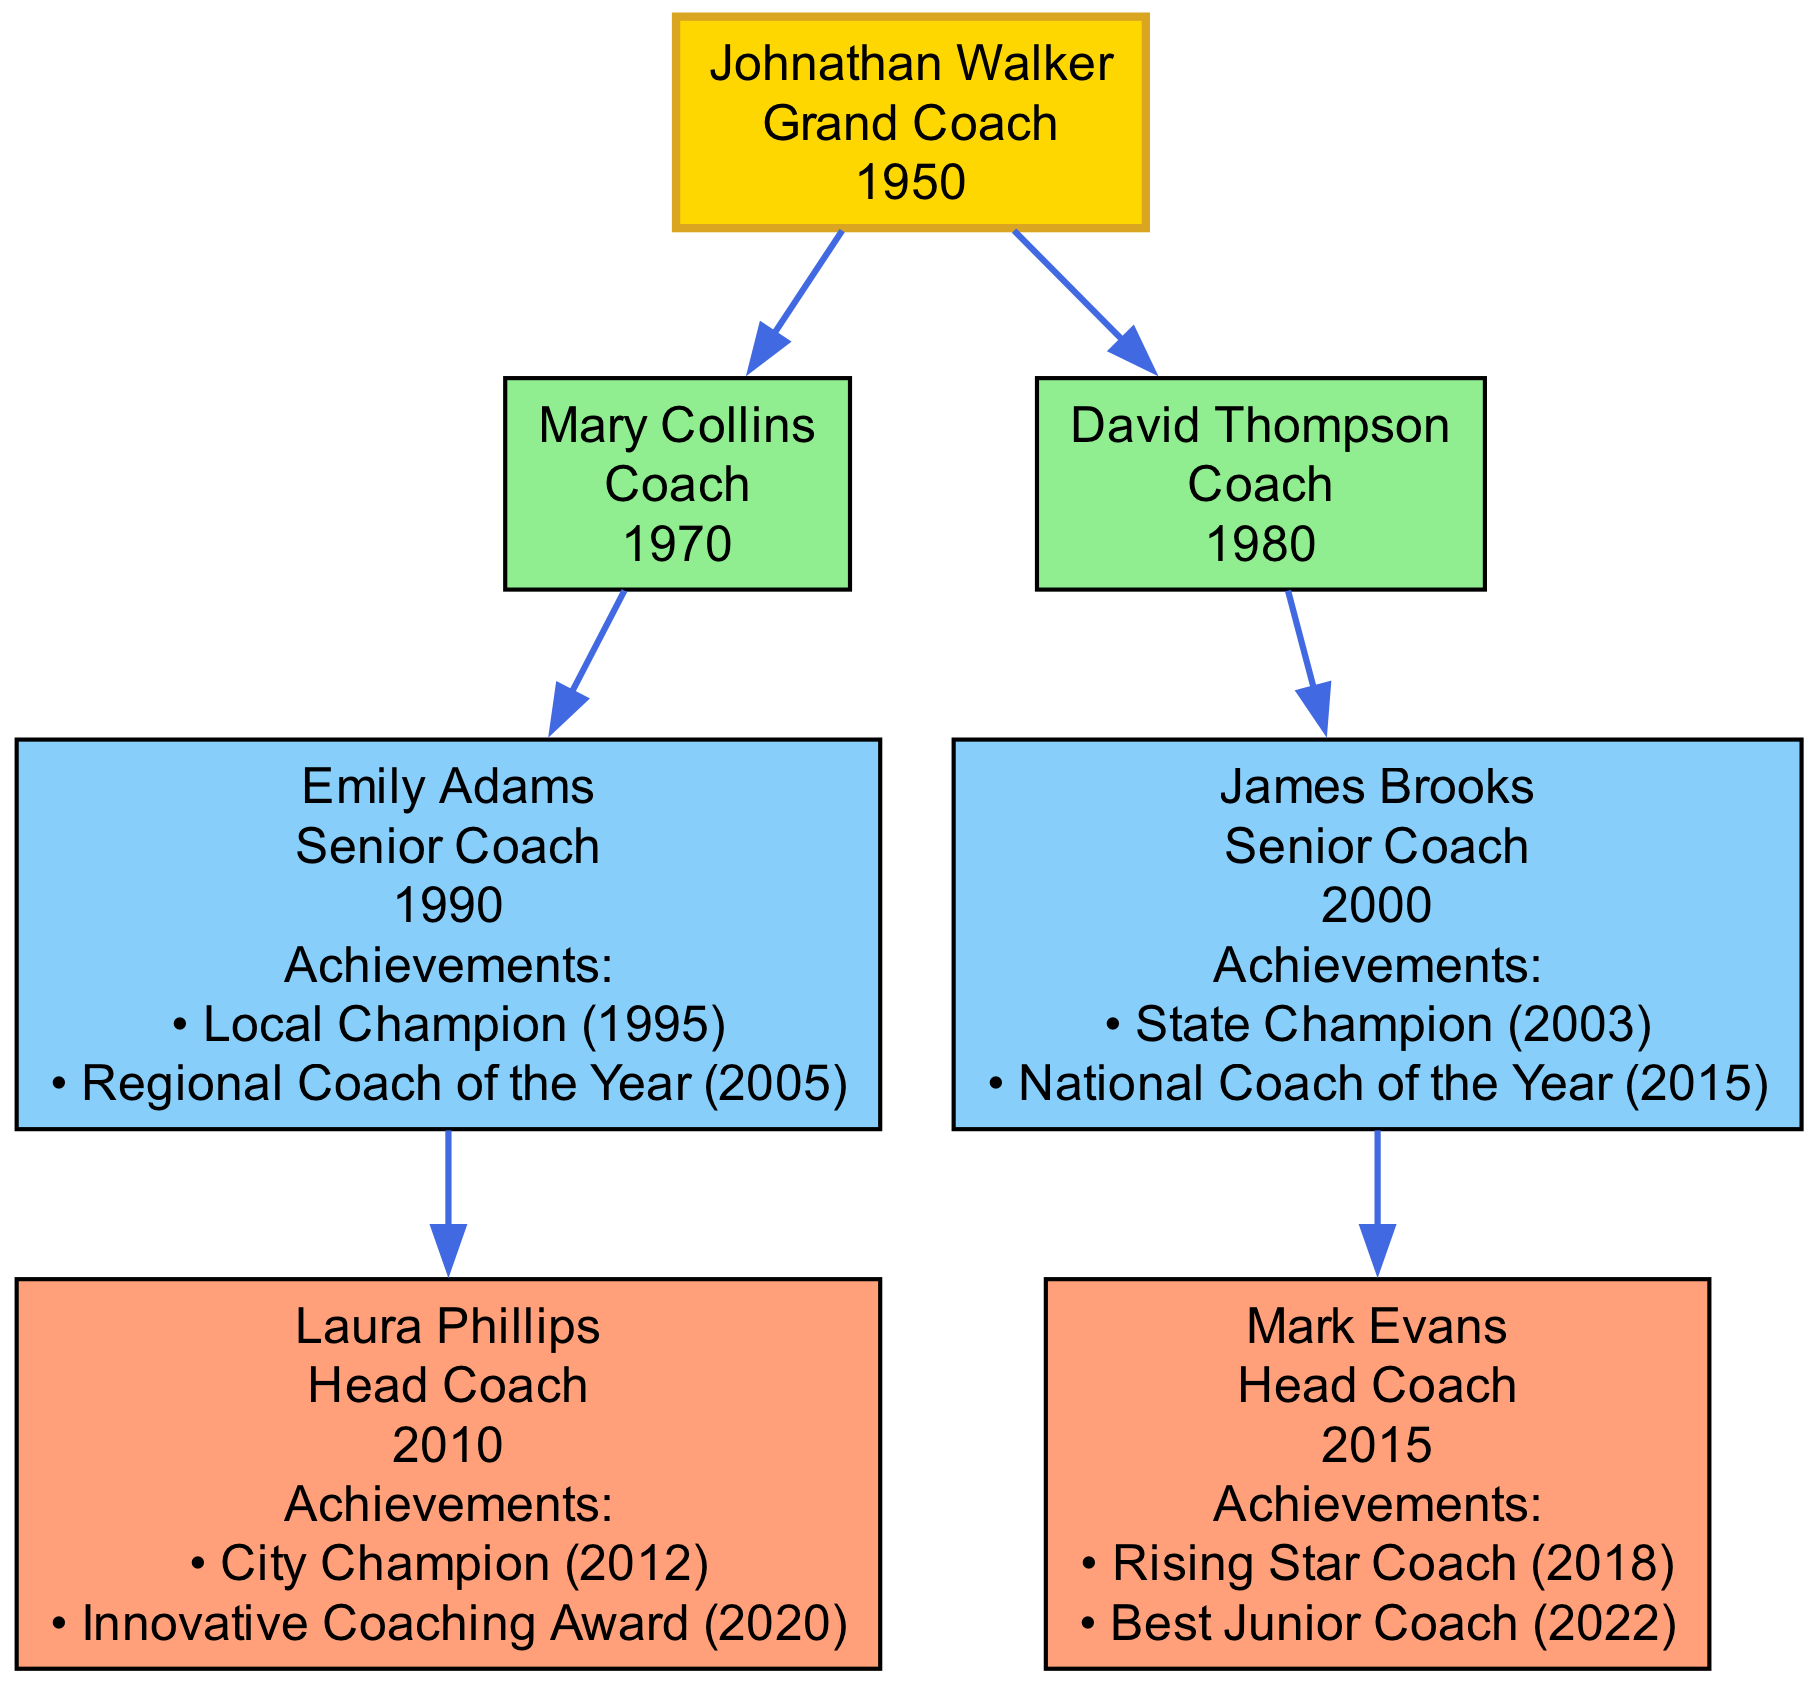What year did Johnathan Walker start? The diagram specifically indicates that Johnathan Walker, the founder, started in the year 1950. This information is directly available in his node.
Answer: 1950 How many influential figures were mentored by Johnathan Walker? By examining the diagram, we see that there are two figures (Mary Collins and David Thompson) directly connected to Johnathan Walker as his mentees.
Answer: 2 Who is the Head Coach mentored by Emily Adams? The diagram shows that Laura Phillips is the Head Coach who was mentored by Emily Adams. This is evident from the edge connecting Emily Adams to Laura Phillips.
Answer: Laura Phillips Which influential figure has the achievement "National Coach of the Year"? The diagram shows that James Brooks has the achievement "National Coach of the Year," which is listed under his node.
Answer: James Brooks What is the role of David Thompson? The diagram explicitly states that David Thompson's role is "Coach," which can be seen in the label of his node.
Answer: Coach Who is the Grand Coach in this family tree? The diagram indicates that Johnathan Walker holds the title of "Grand Coach," as described at the top in his node.
Answer: Johnathan Walker What color represents the Head Coach role in the diagram? In the diagram, nodes representing the Head Coach role, such as Laura Phillips and Mark Evans, are shown in the color #FFA07A, which corresponds to the chosen fill color for that role.
Answer: #FFA07A What is the earliest starting year among the influential figures? After reviewing the starting years listed for each influential figure, the earliest starting year is 1970, which belongs to Mary Collins.
Answer: 1970 How many achievements does Emily Adams have? The diagram shows that Emily Adams has two listed achievements, specifically "Local Champion" in 1995 and "Regional Coach of the Year" in 2005, shown underneath her name in the node.
Answer: 2 